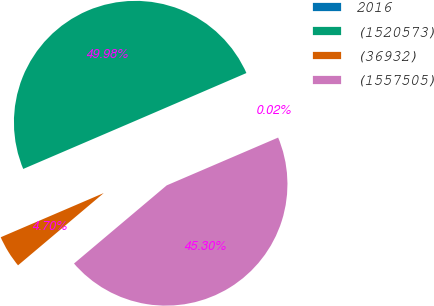<chart> <loc_0><loc_0><loc_500><loc_500><pie_chart><fcel>2016<fcel>(1520573)<fcel>(36932)<fcel>(1557505)<nl><fcel>0.02%<fcel>49.98%<fcel>4.7%<fcel>45.3%<nl></chart> 